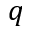<formula> <loc_0><loc_0><loc_500><loc_500>q</formula> 